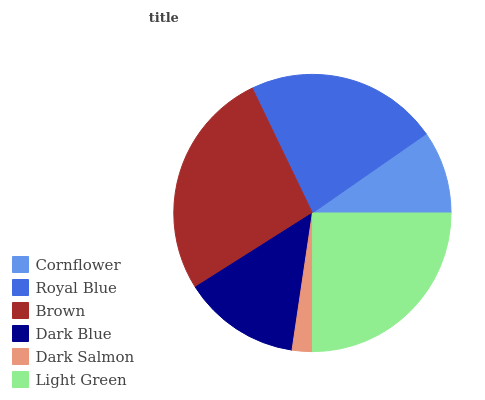Is Dark Salmon the minimum?
Answer yes or no. Yes. Is Brown the maximum?
Answer yes or no. Yes. Is Royal Blue the minimum?
Answer yes or no. No. Is Royal Blue the maximum?
Answer yes or no. No. Is Royal Blue greater than Cornflower?
Answer yes or no. Yes. Is Cornflower less than Royal Blue?
Answer yes or no. Yes. Is Cornflower greater than Royal Blue?
Answer yes or no. No. Is Royal Blue less than Cornflower?
Answer yes or no. No. Is Royal Blue the high median?
Answer yes or no. Yes. Is Dark Blue the low median?
Answer yes or no. Yes. Is Dark Blue the high median?
Answer yes or no. No. Is Dark Salmon the low median?
Answer yes or no. No. 